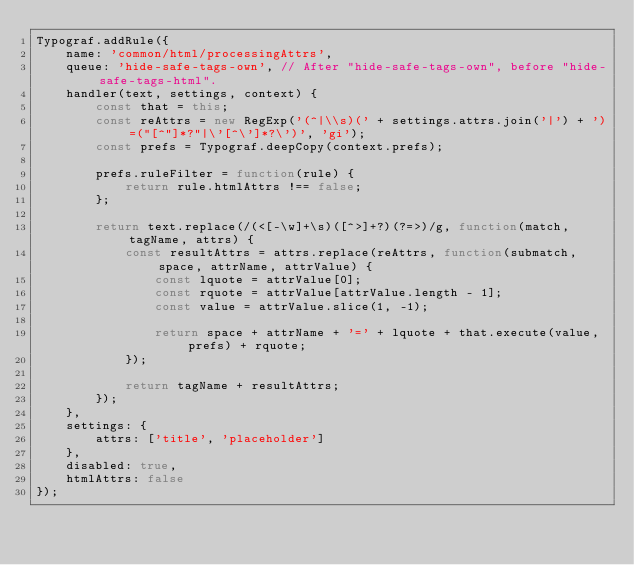<code> <loc_0><loc_0><loc_500><loc_500><_JavaScript_>Typograf.addRule({
    name: 'common/html/processingAttrs',
    queue: 'hide-safe-tags-own', // After "hide-safe-tags-own", before "hide-safe-tags-html".
    handler(text, settings, context) {
        const that = this;
        const reAttrs = new RegExp('(^|\\s)(' + settings.attrs.join('|') + ')=("[^"]*?"|\'[^\']*?\')', 'gi');
        const prefs = Typograf.deepCopy(context.prefs);

        prefs.ruleFilter = function(rule) {
            return rule.htmlAttrs !== false;
        };

        return text.replace(/(<[-\w]+\s)([^>]+?)(?=>)/g, function(match, tagName, attrs) {
            const resultAttrs = attrs.replace(reAttrs, function(submatch, space, attrName, attrValue) {
                const lquote = attrValue[0];
                const rquote = attrValue[attrValue.length - 1];
                const value = attrValue.slice(1, -1);

                return space + attrName + '=' + lquote + that.execute(value, prefs) + rquote;
            });

            return tagName + resultAttrs;
        });
    },
    settings: {
        attrs: ['title', 'placeholder']
    },
    disabled: true,
    htmlAttrs: false
});
</code> 